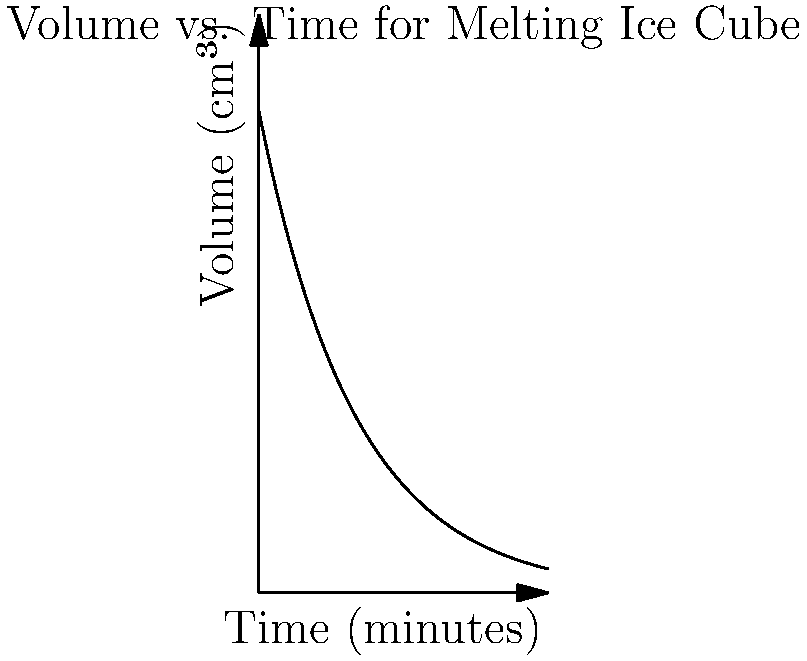A Danish student is studying the melting process of an ice cube for the first time. The volume $V$ (in cm³) of the ice cube at time $t$ (in minutes) is given by the function $V(t) = 100e^{-0.05t}$. What is the rate of change of the ice cube's volume when its volume is 80 cm³? Let's approach this step-by-step:

1) We're given that $V(t) = 100e^{-0.05t}$.

2) To find the rate of change, we need to differentiate $V(t)$ with respect to $t$:
   
   $\frac{dV}{dt} = 100 \cdot (-0.05) \cdot e^{-0.05t} = -5e^{-0.05t}$

3) We want to find this rate when $V = 80$ cm³. We need to find $t$ when $V = 80$:
   
   $80 = 100e^{-0.05t}$
   
   $0.8 = e^{-0.05t}$
   
   $\ln(0.8) = -0.05t$
   
   $t = -\frac{\ln(0.8)}{0.05} \approx 4.46$ minutes

4) Now we can substitute this $t$ value into our rate of change function:
   
   $\frac{dV}{dt} = -5e^{-0.05(4.46)} = -5 \cdot 0.8 = -4$ cm³/min

5) Therefore, when the volume is 80 cm³, the rate of change is -4 cm³/min.

The negative sign indicates that the volume is decreasing over time, which makes sense for a melting ice cube.
Answer: $-4$ cm³/min 